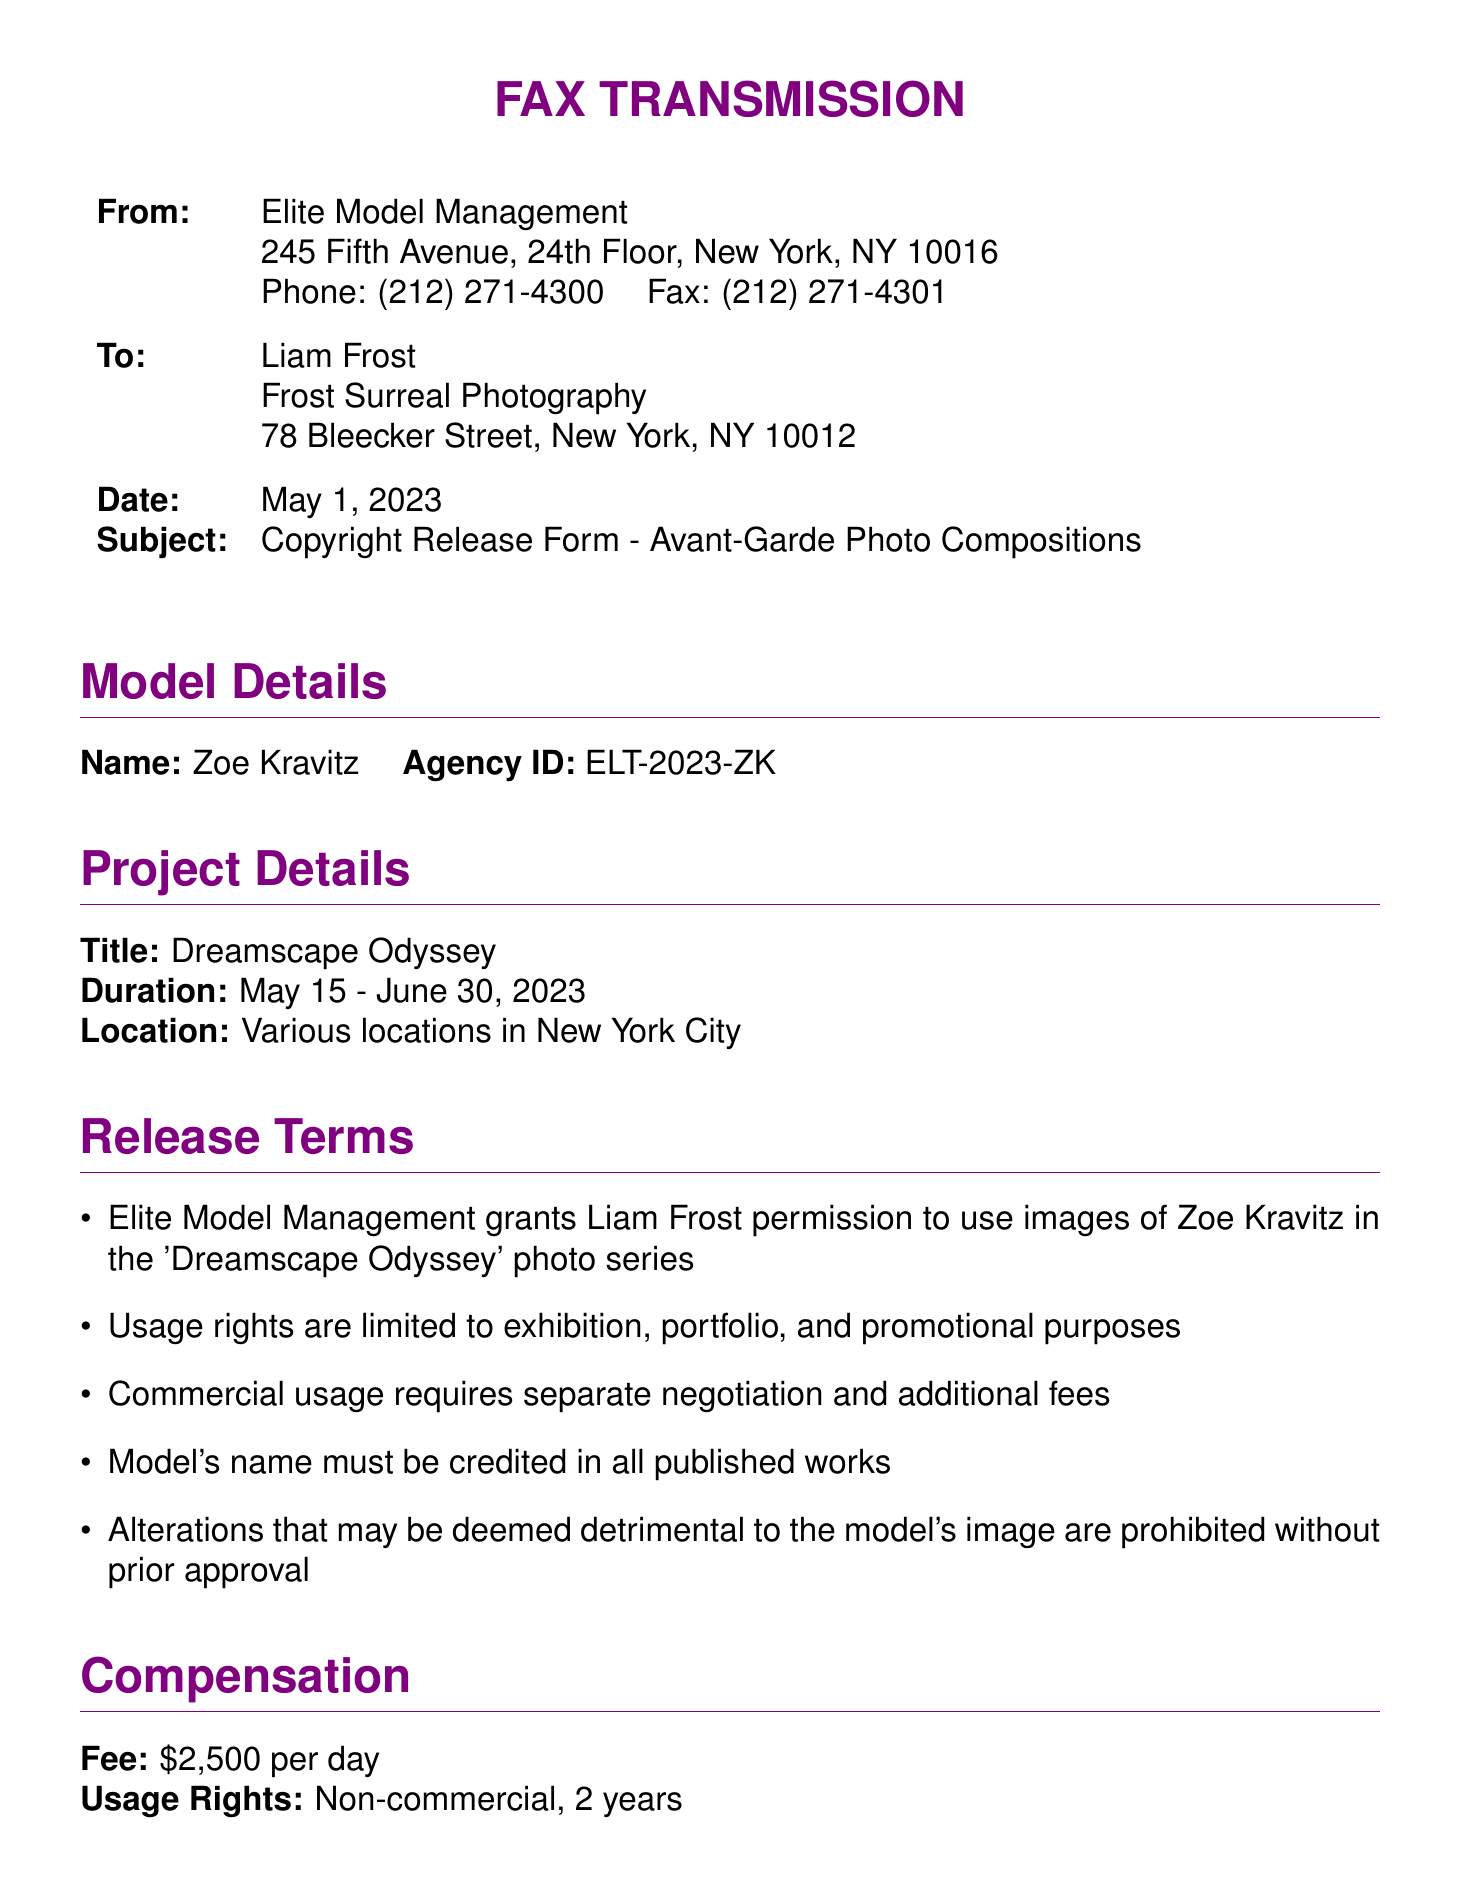What is the agency involved? The document specifies the agency granting the release, which is Elite Model Management.
Answer: Elite Model Management Who is the model in the photo series? The document mentions the model's name along with her details.
Answer: Zoe Kravitz What is the project title? The title of the photo series is explicitly stated in the document.
Answer: Dreamscape Odyssey What is the duration of the project? The document provides the start and end dates for the project duration.
Answer: May 15 - June 30, 2023 How much is the daily fee for the model? The document states the compensation fee for the model's participation per day.
Answer: $2,500 What are the usage rights for the images? The document outlines specific rights associated with the use of the model's images.
Answer: Non-commercial, 2 years Who is the agency representative listed? The document mentions the talent manager from the agency.
Answer: Sarah Thompson What is prohibited without prior approval according to the release terms? The release terms in the document highlight what alterations require prior consent.
Answer: Detrimental alterations What is the location of the project? The document indicates where the photo series is to be conducted.
Answer: Various locations in New York City 